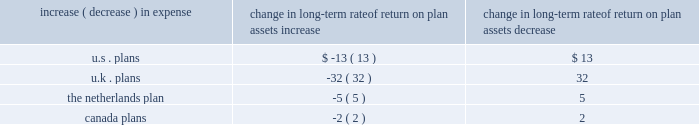Holding other assumptions constant , the table reflects what a one hundred basis point increase and decrease in our estimated long-term rate of return on plan assets would have on our estimated 2010 pension expense ( in millions ) : change in long-term rate of return on plan assets .
Estimated future contributions we estimate contributions of approximately $ 381 million in 2010 as compared with $ 437 million in goodwill and other intangible assets goodwill represents the excess of cost over the fair market value of the net assets acquired .
We classify our intangible assets acquired as either trademarks , client lists , non-compete agreements , or other purchased intangibles .
Our goodwill and other intangible balances at december 31 , 2009 were $ 6.1 billion and $ 791 million , respectively , compared to $ 5.6 billion and $ 779 million , respectively , at december 31 , 2008 .
Although goodwill is not amortized , we test it for impairment at least annually in the fourth quarter .
Beginning in 2009 , we also test trademarks ( which also are not amortized ) that were acquired in conjunction with the benfield merger for impairment .
We test more frequently if there are indicators of impairment or whenever business circumstances suggest that the carrying value of goodwill or trademarks may not be recoverable .
These indicators may include a sustained significant decline in our share price and market capitalization , a decline in our expected future cash flows , or a significant adverse change in legal factors or in the business climate , among others .
No events occurred during 2009 or 2008 that indicate the existence of an impairment with respect to our reported goodwill or trademarks .
We perform impairment reviews at the reporting unit level .
A reporting unit is an operating segment or one level below an operating segment ( referred to as a 2018 2018component 2019 2019 ) .
A component of an operating segment is a reporting unit if the component constitutes a business for which discrete financial information is available and segment management regularly reviews the operating results of that component .
An operating segment shall be deemed to be a reporting unit if all of its components are similar , if none of its components is a reporting unit , or if the segment comprises only a single component .
The goodwill impairment test is a two step analysis .
Step one requires the fair value of each reporting unit to be compared to its book value .
Management must apply judgment in determining the estimated fair value of the reporting units .
If the fair value of a reporting unit is determined to be greater than the carrying value of the reporting unit , goodwill and trademarks are deemed not to be impaired and no further testing is necessary .
If the fair value of a reporting unit is less than the carrying value , we perform step two .
Step two uses the calculated fair value of the reporting unit to perform a hypothetical purchase price allocation to the fair value of the assets and liabilities of the reporting unit .
The difference between the fair value of the reporting unit calculated in step one and the fair value of the underlying assets and liabilities of the reporting unit is the implied fair value of .
Considering the year 2010 , what is the difference between the expected contributions and the goodwill and other intangible assets value , in millions? 
Rationale: it is the variation between those values .
Computations: (437 - 381)
Answer: 56.0. Holding other assumptions constant , the table reflects what a one hundred basis point increase and decrease in our estimated long-term rate of return on plan assets would have on our estimated 2010 pension expense ( in millions ) : change in long-term rate of return on plan assets .
Estimated future contributions we estimate contributions of approximately $ 381 million in 2010 as compared with $ 437 million in goodwill and other intangible assets goodwill represents the excess of cost over the fair market value of the net assets acquired .
We classify our intangible assets acquired as either trademarks , client lists , non-compete agreements , or other purchased intangibles .
Our goodwill and other intangible balances at december 31 , 2009 were $ 6.1 billion and $ 791 million , respectively , compared to $ 5.6 billion and $ 779 million , respectively , at december 31 , 2008 .
Although goodwill is not amortized , we test it for impairment at least annually in the fourth quarter .
Beginning in 2009 , we also test trademarks ( which also are not amortized ) that were acquired in conjunction with the benfield merger for impairment .
We test more frequently if there are indicators of impairment or whenever business circumstances suggest that the carrying value of goodwill or trademarks may not be recoverable .
These indicators may include a sustained significant decline in our share price and market capitalization , a decline in our expected future cash flows , or a significant adverse change in legal factors or in the business climate , among others .
No events occurred during 2009 or 2008 that indicate the existence of an impairment with respect to our reported goodwill or trademarks .
We perform impairment reviews at the reporting unit level .
A reporting unit is an operating segment or one level below an operating segment ( referred to as a 2018 2018component 2019 2019 ) .
A component of an operating segment is a reporting unit if the component constitutes a business for which discrete financial information is available and segment management regularly reviews the operating results of that component .
An operating segment shall be deemed to be a reporting unit if all of its components are similar , if none of its components is a reporting unit , or if the segment comprises only a single component .
The goodwill impairment test is a two step analysis .
Step one requires the fair value of each reporting unit to be compared to its book value .
Management must apply judgment in determining the estimated fair value of the reporting units .
If the fair value of a reporting unit is determined to be greater than the carrying value of the reporting unit , goodwill and trademarks are deemed not to be impaired and no further testing is necessary .
If the fair value of a reporting unit is less than the carrying value , we perform step two .
Step two uses the calculated fair value of the reporting unit to perform a hypothetical purchase price allocation to the fair value of the assets and liabilities of the reporting unit .
The difference between the fair value of the reporting unit calculated in step one and the fair value of the underlying assets and liabilities of the reporting unit is the implied fair value of .
What is the increase in the value of goodwill balances during 2008 and 2009? 
Rationale: it is the 2009's goodwill divided by the 2008's , then turned into a percentage to represent the increase .
Computations: ((6.1 / 5.6) - 1)
Answer: 0.08929. 